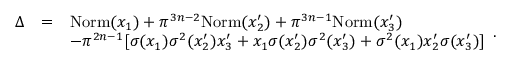Convert formula to latex. <formula><loc_0><loc_0><loc_500><loc_500>\begin{array} { l l l } { \Delta } & { = } & { N o r m ( x _ { 1 } ) + \pi ^ { 3 n - 2 } N o r m ( x _ { 2 } ^ { \prime } ) + \pi ^ { 3 n - 1 } N o r m ( x _ { 3 } ^ { \prime } ) } \\ & & { - \pi ^ { 2 n - 1 } [ \sigma ( x _ { 1 } ) \sigma ^ { 2 } ( x _ { 2 } ^ { \prime } ) x _ { 3 } ^ { \prime } + x _ { 1 } \sigma ( x _ { 2 } ^ { \prime } ) \sigma ^ { 2 } ( x _ { 3 } ^ { \prime } ) + \sigma ^ { 2 } ( x _ { 1 } ) x _ { 2 } ^ { \prime } \sigma ( x _ { 3 } ^ { \prime } ) ] } \end{array} .</formula> 